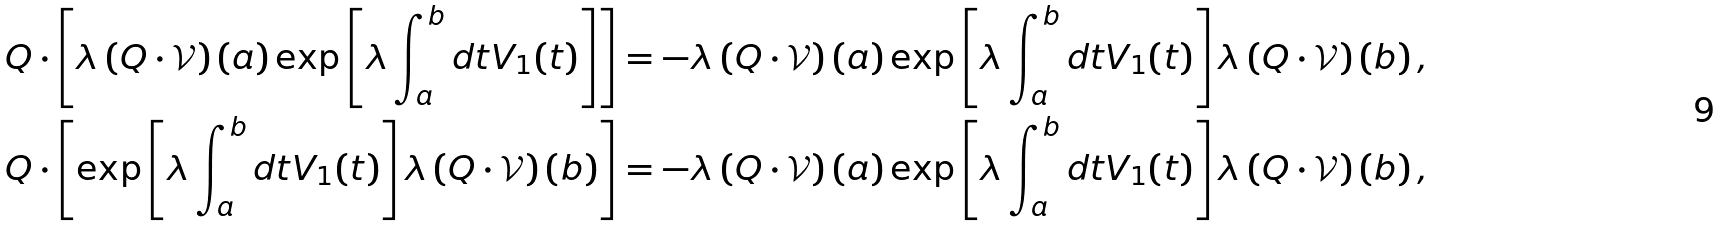Convert formula to latex. <formula><loc_0><loc_0><loc_500><loc_500>Q \cdot \left [ \lambda \left ( Q \cdot \mathcal { V } \right ) ( a ) \exp \left [ \lambda \int _ { a } ^ { b } d t V _ { 1 } ( t ) \right ] \right ] & = - \lambda \left ( Q \cdot \mathcal { V } \right ) ( a ) \exp \left [ \lambda \int _ { a } ^ { b } d t V _ { 1 } ( t ) \right ] \lambda \left ( Q \cdot \mathcal { V } \right ) ( b ) \, , \\ Q \cdot \left [ \exp \left [ \lambda \int _ { a } ^ { b } d t V _ { 1 } ( t ) \right ] \lambda \left ( Q \cdot \mathcal { V } \right ) ( b ) \right ] & = - \lambda \left ( Q \cdot \mathcal { V } \right ) ( a ) \exp \left [ \lambda \int _ { a } ^ { b } d t V _ { 1 } ( t ) \right ] \lambda \left ( Q \cdot \mathcal { V } \right ) ( b ) \, ,</formula> 